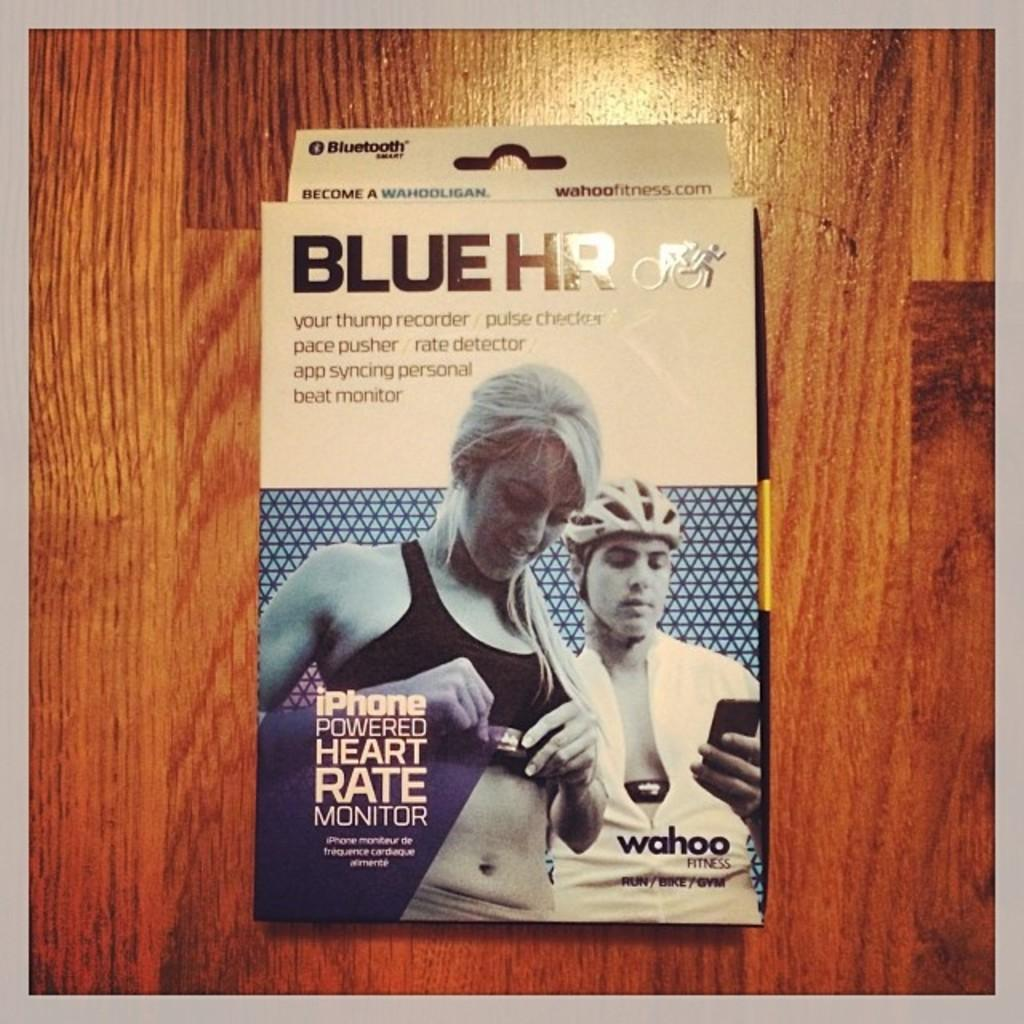<image>
Provide a brief description of the given image. A Blue HR Iphone powered heart Rate monitor. 